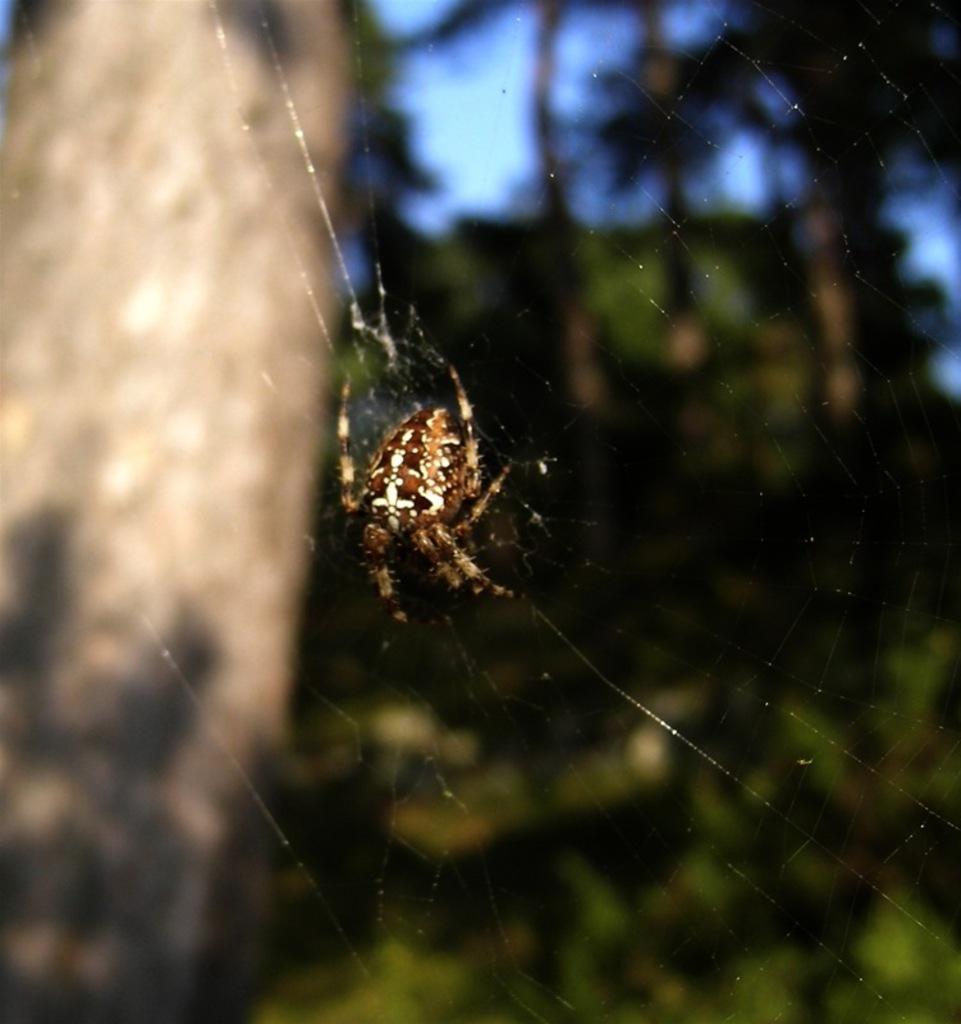How would you summarize this image in a sentence or two? In this image I can see the spider in brown and cream color. In the background I can see few trees in green color and the sky is in blue color. 